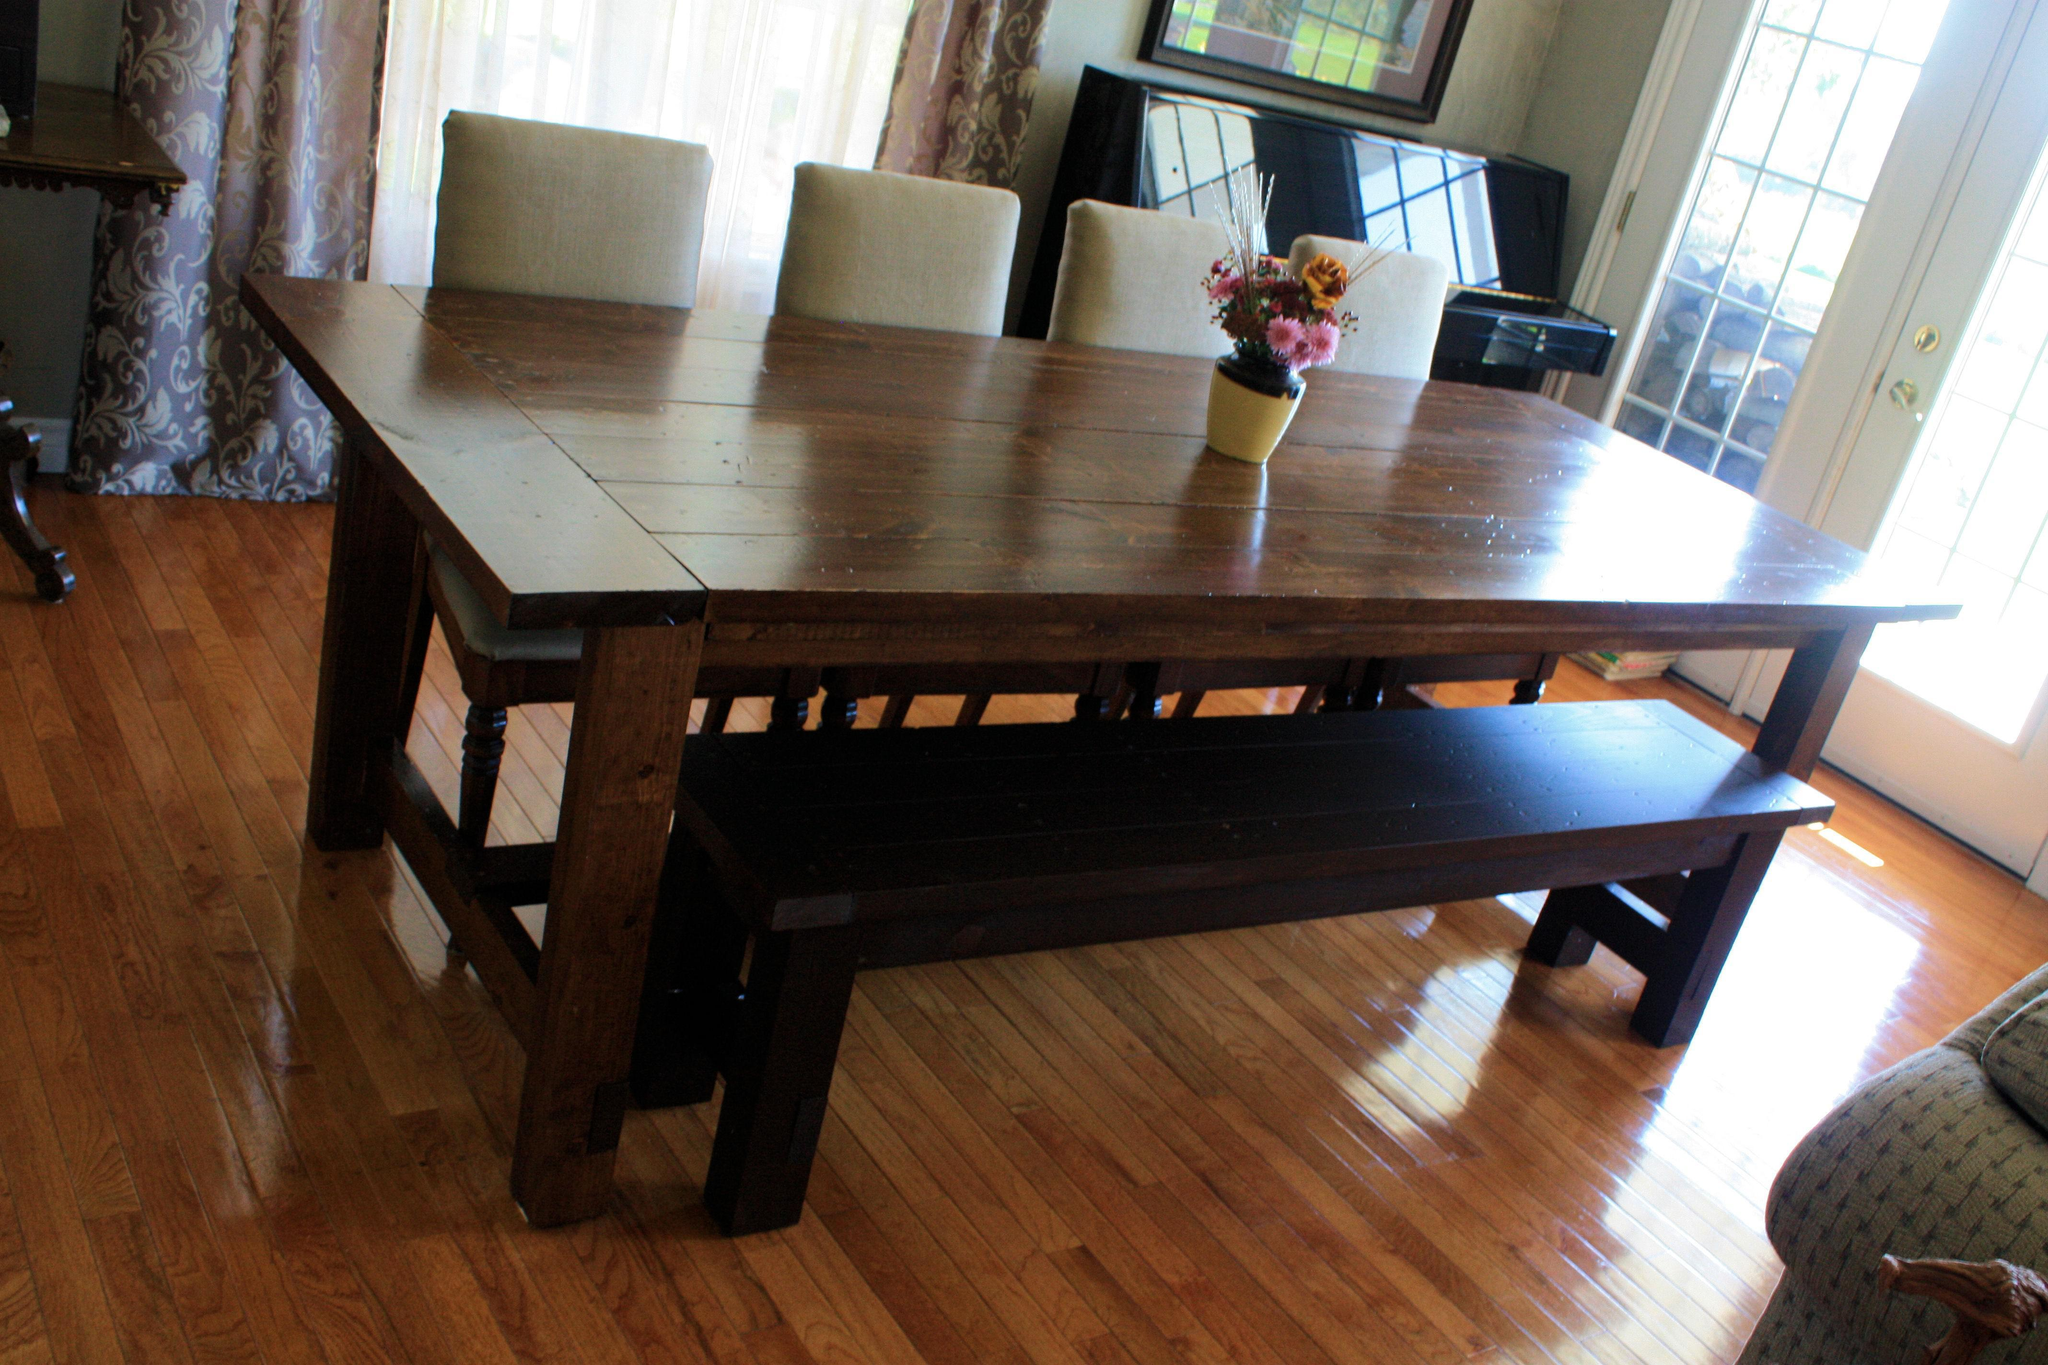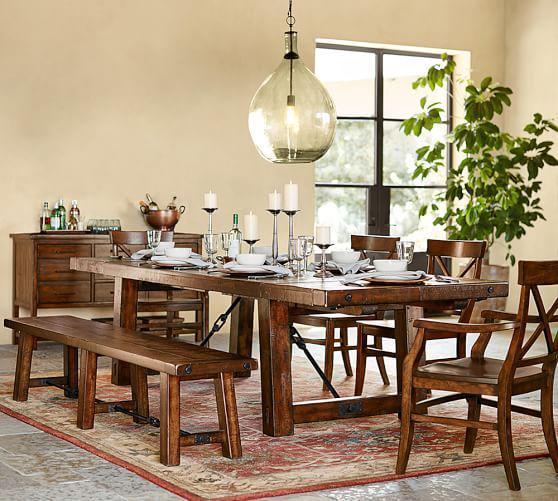The first image is the image on the left, the second image is the image on the right. For the images displayed, is the sentence "there is a wooden dining table with a bench as one of the seats with 3 pendent lights above the table" factually correct? Answer yes or no. No. 